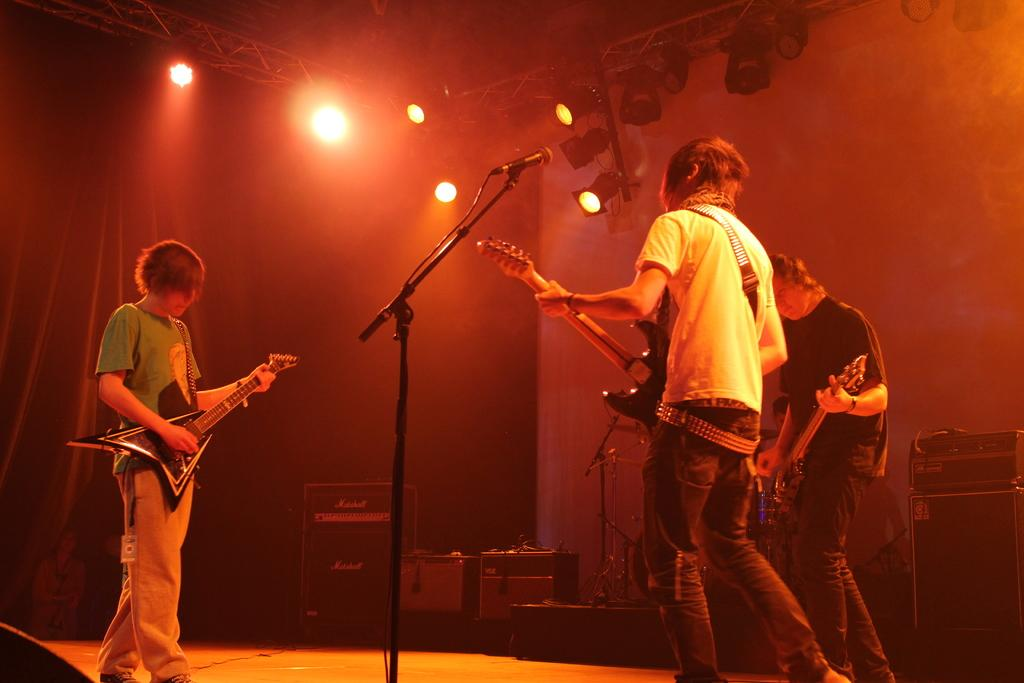How many people are in the image? There are three men in the image. What are the men doing in the image? The men are playing guitars. What is in front of the men? There is a microphone in front of the men. What can be seen in the background of the image? Colorful lights are present in the image. What other musical instruments can be seen in the image? There are other musical instruments in the image. What type of pancake is being served during the band's performance in the image? There is no pancake present in the image, nor is there any indication of a band performing or serving food. 